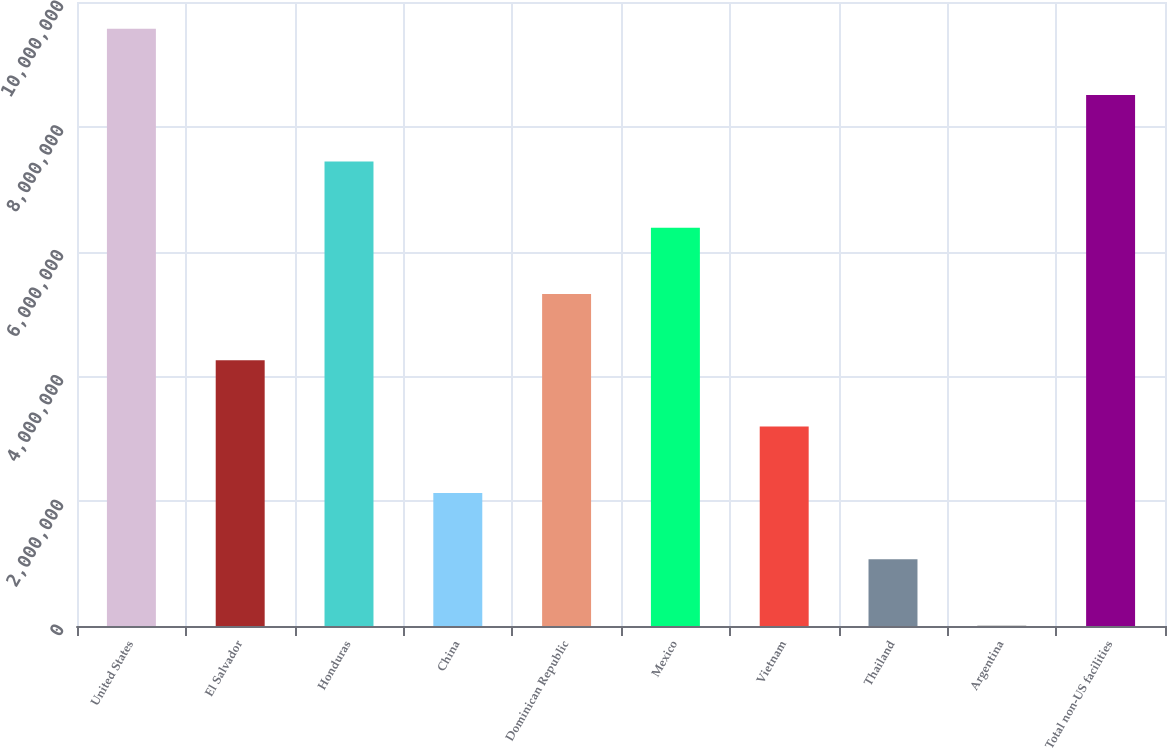Convert chart to OTSL. <chart><loc_0><loc_0><loc_500><loc_500><bar_chart><fcel>United States<fcel>El Salvador<fcel>Honduras<fcel>China<fcel>Dominican Republic<fcel>Mexico<fcel>Vietnam<fcel>Thailand<fcel>Argentina<fcel>Total non-US facilities<nl><fcel>9.57086e+06<fcel>4.25796e+06<fcel>7.4457e+06<fcel>2.1328e+06<fcel>5.32054e+06<fcel>6.38312e+06<fcel>3.19538e+06<fcel>1.07022e+06<fcel>7642<fcel>8.50828e+06<nl></chart> 